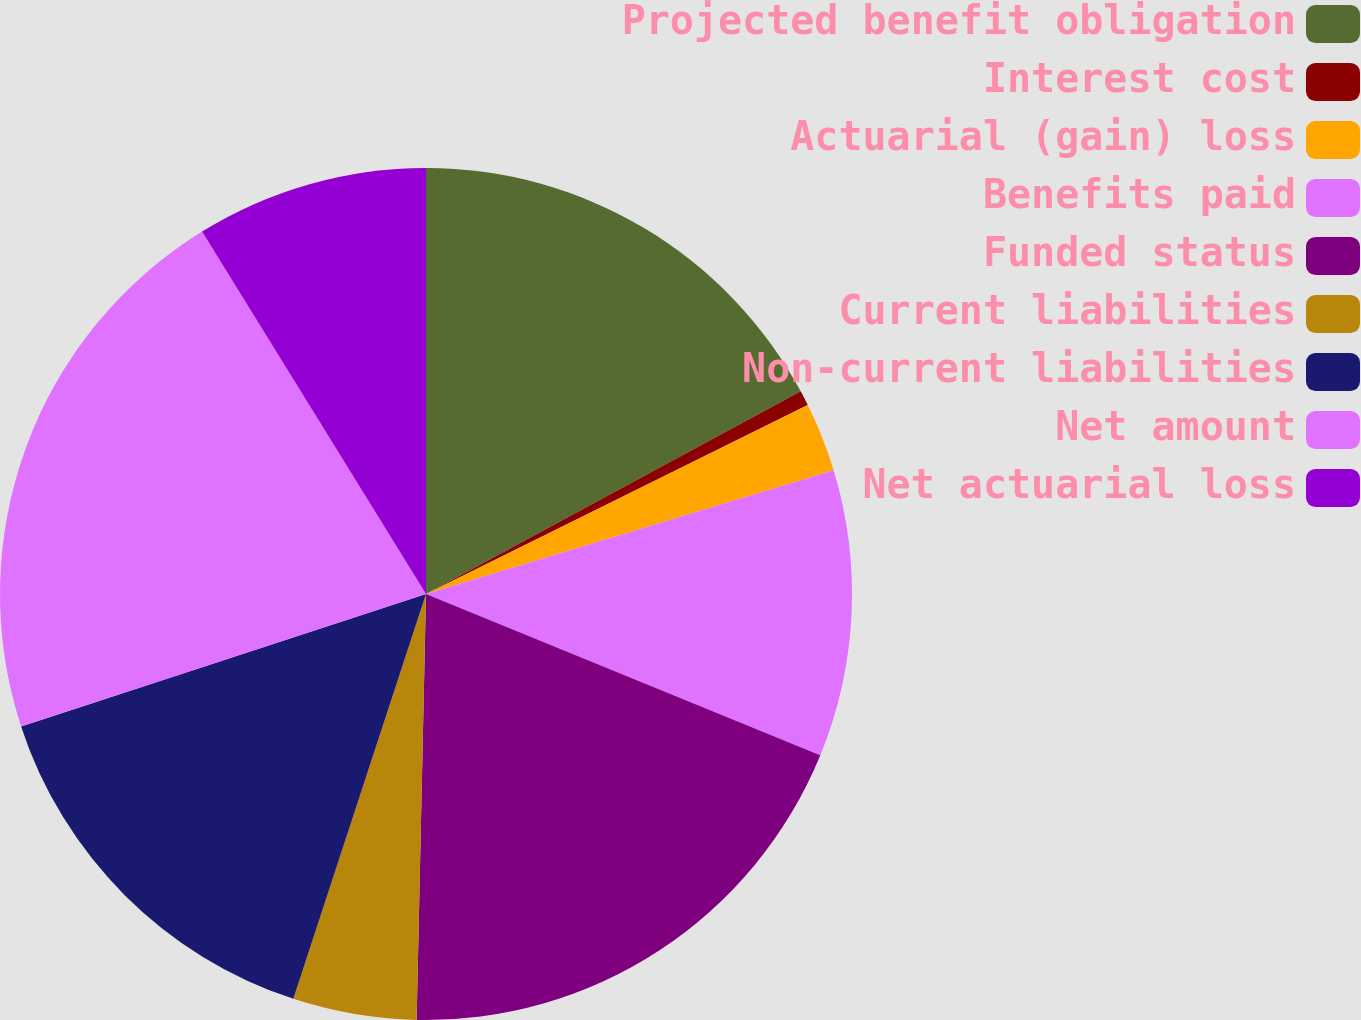Convert chart. <chart><loc_0><loc_0><loc_500><loc_500><pie_chart><fcel>Projected benefit obligation<fcel>Interest cost<fcel>Actuarial (gain) loss<fcel>Benefits paid<fcel>Funded status<fcel>Current liabilities<fcel>Non-current liabilities<fcel>Net amount<fcel>Net actuarial loss<nl><fcel>17.11%<fcel>0.57%<fcel>2.63%<fcel>10.87%<fcel>19.17%<fcel>4.69%<fcel>14.93%<fcel>21.22%<fcel>8.81%<nl></chart> 